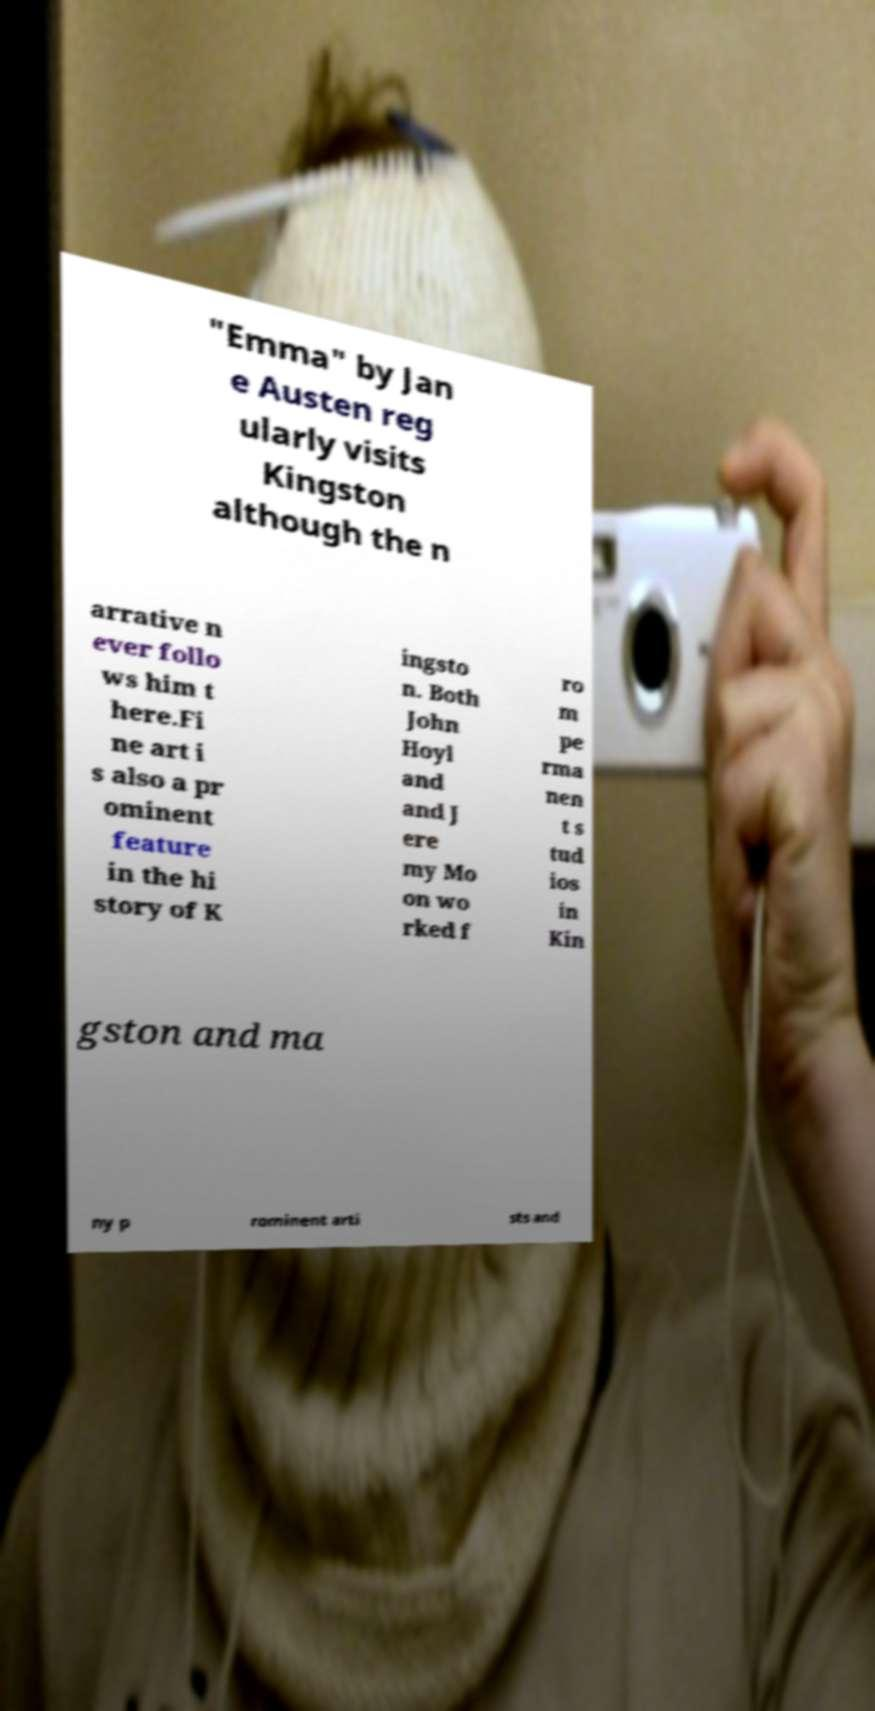Could you assist in decoding the text presented in this image and type it out clearly? "Emma" by Jan e Austen reg ularly visits Kingston although the n arrative n ever follo ws him t here.Fi ne art i s also a pr ominent feature in the hi story of K ingsto n. Both John Hoyl and and J ere my Mo on wo rked f ro m pe rma nen t s tud ios in Kin gston and ma ny p rominent arti sts and 